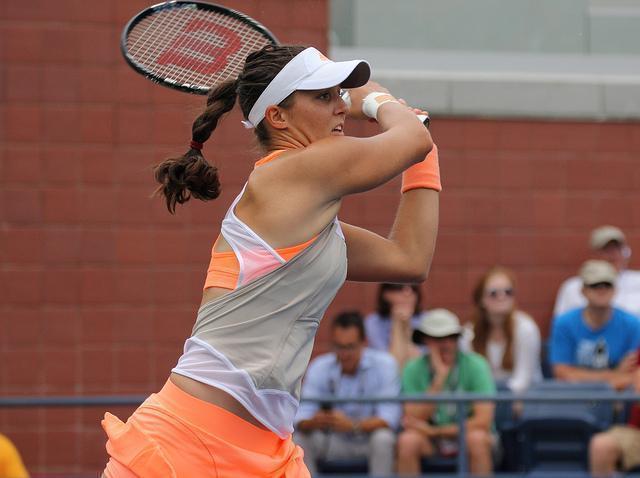What brand of tennis racket is she using to play?
Select the accurate answer and provide justification: `Answer: choice
Rationale: srationale.`
Options: Sportscraft, wilson, head, nike. Answer: head.
Rationale: The tennis racket has the logo for wilson on it. 